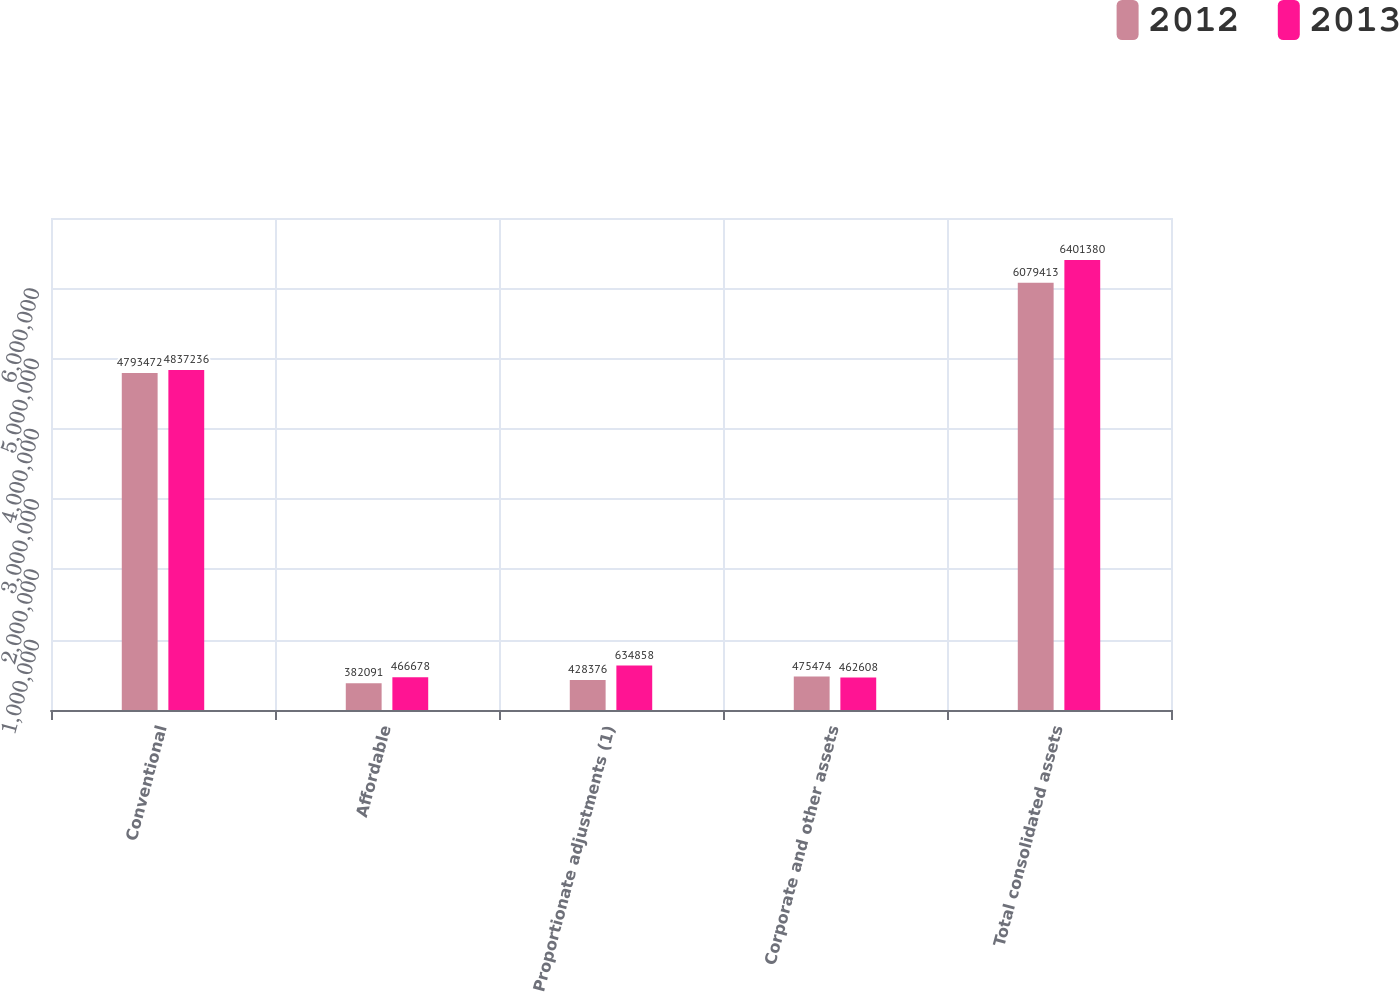<chart> <loc_0><loc_0><loc_500><loc_500><stacked_bar_chart><ecel><fcel>Conventional<fcel>Affordable<fcel>Proportionate adjustments (1)<fcel>Corporate and other assets<fcel>Total consolidated assets<nl><fcel>2012<fcel>4.79347e+06<fcel>382091<fcel>428376<fcel>475474<fcel>6.07941e+06<nl><fcel>2013<fcel>4.83724e+06<fcel>466678<fcel>634858<fcel>462608<fcel>6.40138e+06<nl></chart> 